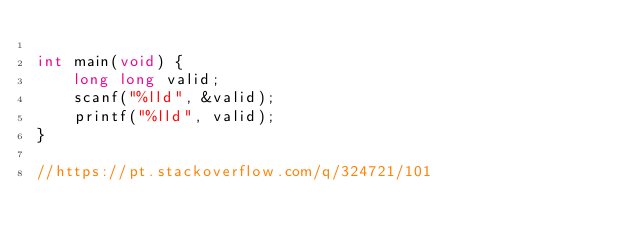Convert code to text. <code><loc_0><loc_0><loc_500><loc_500><_C_>
int main(void) {
    long long valid;
    scanf("%lld", &valid);
    printf("%lld", valid);
}

//https://pt.stackoverflow.com/q/324721/101
</code> 